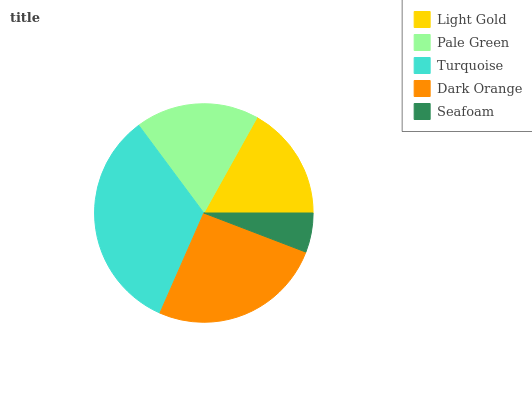Is Seafoam the minimum?
Answer yes or no. Yes. Is Turquoise the maximum?
Answer yes or no. Yes. Is Pale Green the minimum?
Answer yes or no. No. Is Pale Green the maximum?
Answer yes or no. No. Is Pale Green greater than Light Gold?
Answer yes or no. Yes. Is Light Gold less than Pale Green?
Answer yes or no. Yes. Is Light Gold greater than Pale Green?
Answer yes or no. No. Is Pale Green less than Light Gold?
Answer yes or no. No. Is Pale Green the high median?
Answer yes or no. Yes. Is Pale Green the low median?
Answer yes or no. Yes. Is Light Gold the high median?
Answer yes or no. No. Is Light Gold the low median?
Answer yes or no. No. 